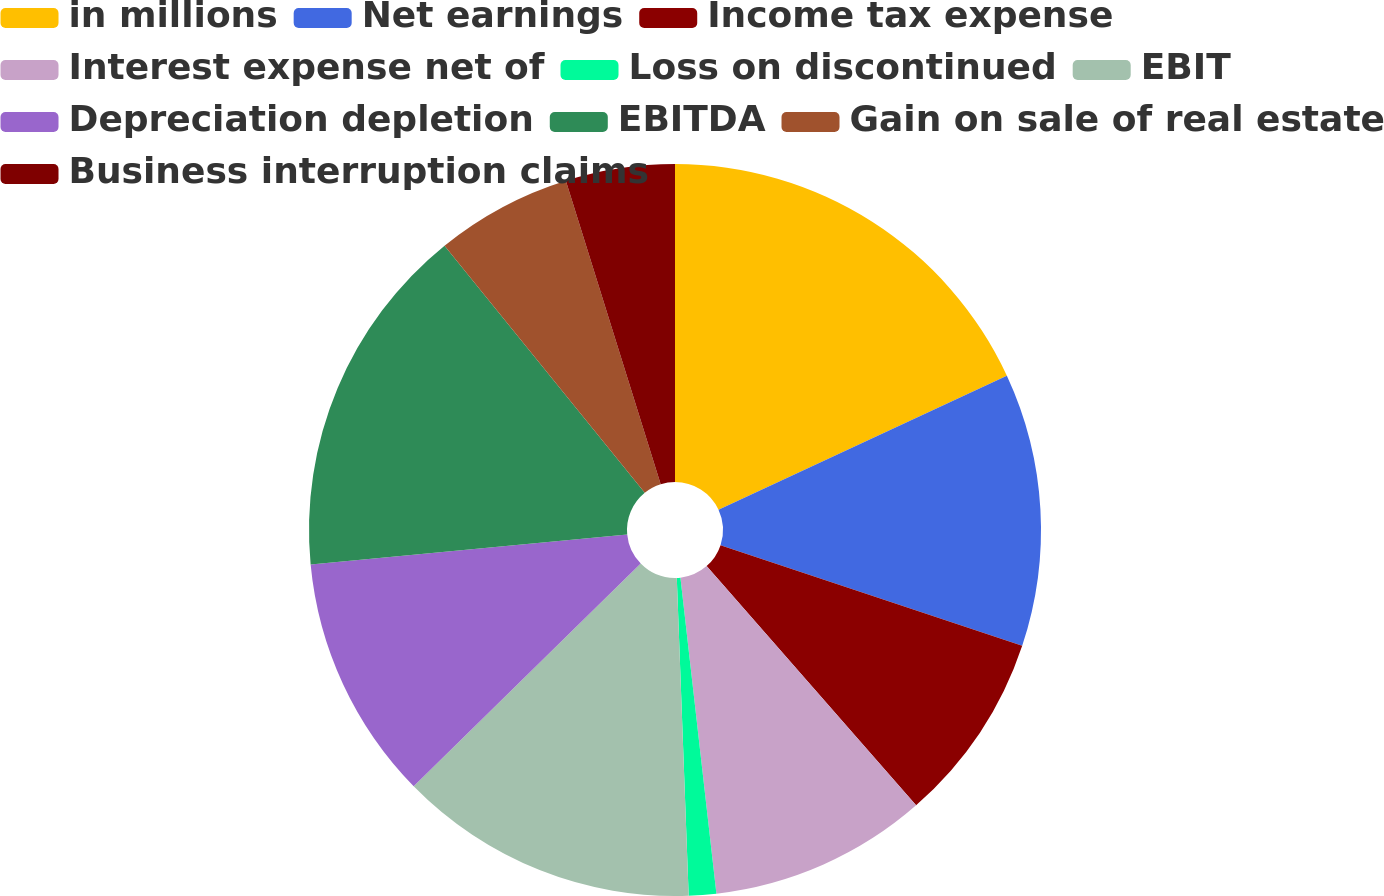Convert chart. <chart><loc_0><loc_0><loc_500><loc_500><pie_chart><fcel>in millions<fcel>Net earnings<fcel>Income tax expense<fcel>Interest expense net of<fcel>Loss on discontinued<fcel>EBIT<fcel>Depreciation depletion<fcel>EBITDA<fcel>Gain on sale of real estate<fcel>Business interruption claims<nl><fcel>18.07%<fcel>12.05%<fcel>8.43%<fcel>9.64%<fcel>1.21%<fcel>13.25%<fcel>10.84%<fcel>15.66%<fcel>6.02%<fcel>4.82%<nl></chart> 